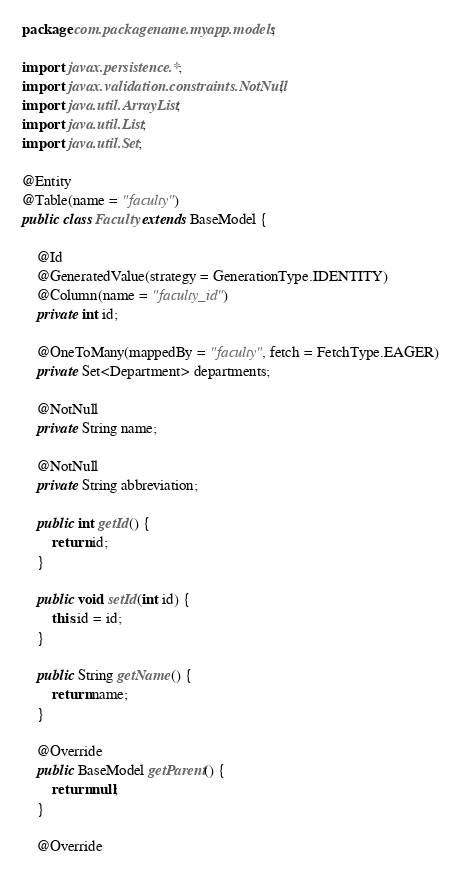Convert code to text. <code><loc_0><loc_0><loc_500><loc_500><_Java_>package com.packagename.myapp.models;

import javax.persistence.*;
import javax.validation.constraints.NotNull;
import java.util.ArrayList;
import java.util.List;
import java.util.Set;

@Entity
@Table(name = "faculty")
public class Faculty extends BaseModel {

    @Id
    @GeneratedValue(strategy = GenerationType.IDENTITY)
    @Column(name = "faculty_id")
    private int id;

    @OneToMany(mappedBy = "faculty", fetch = FetchType.EAGER)
    private Set<Department> departments;

    @NotNull
    private String name;

    @NotNull
    private String abbreviation;

    public int getId() {
        return id;
    }

    public void setId(int id) {
        this.id = id;
    }

    public String getName() {
        return name;
    }

    @Override
    public BaseModel getParent() {
        return null;
    }

    @Override</code> 